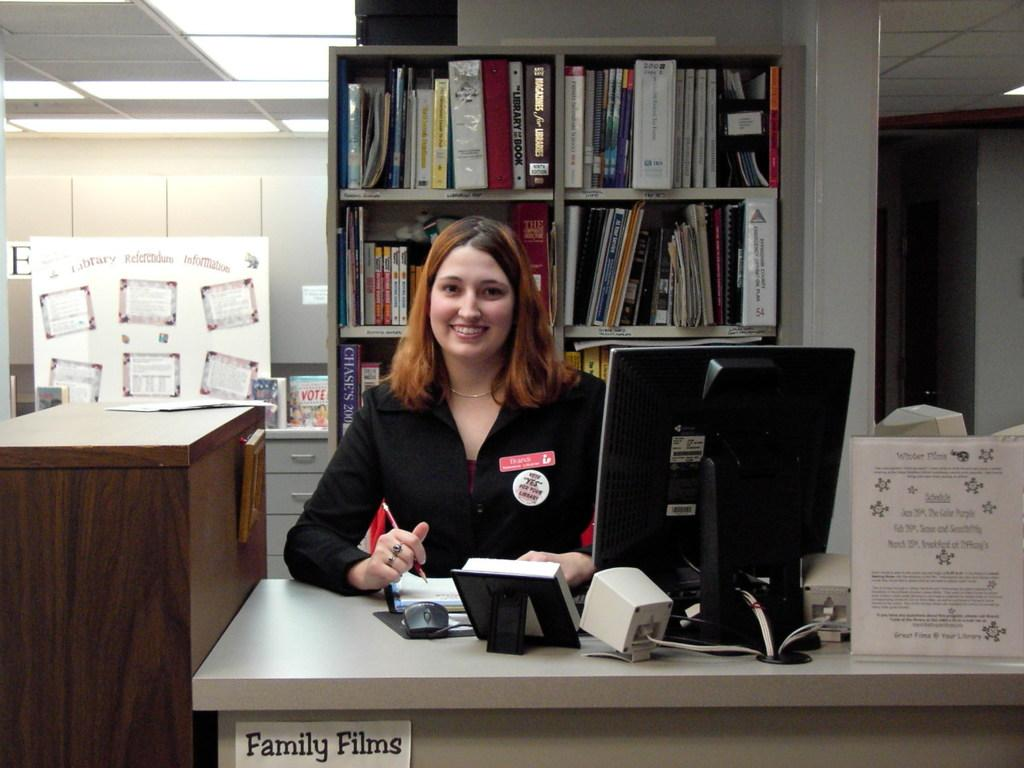Provide a one-sentence caption for the provided image. A young woman sits at a desk that is labelled "Family Films". 